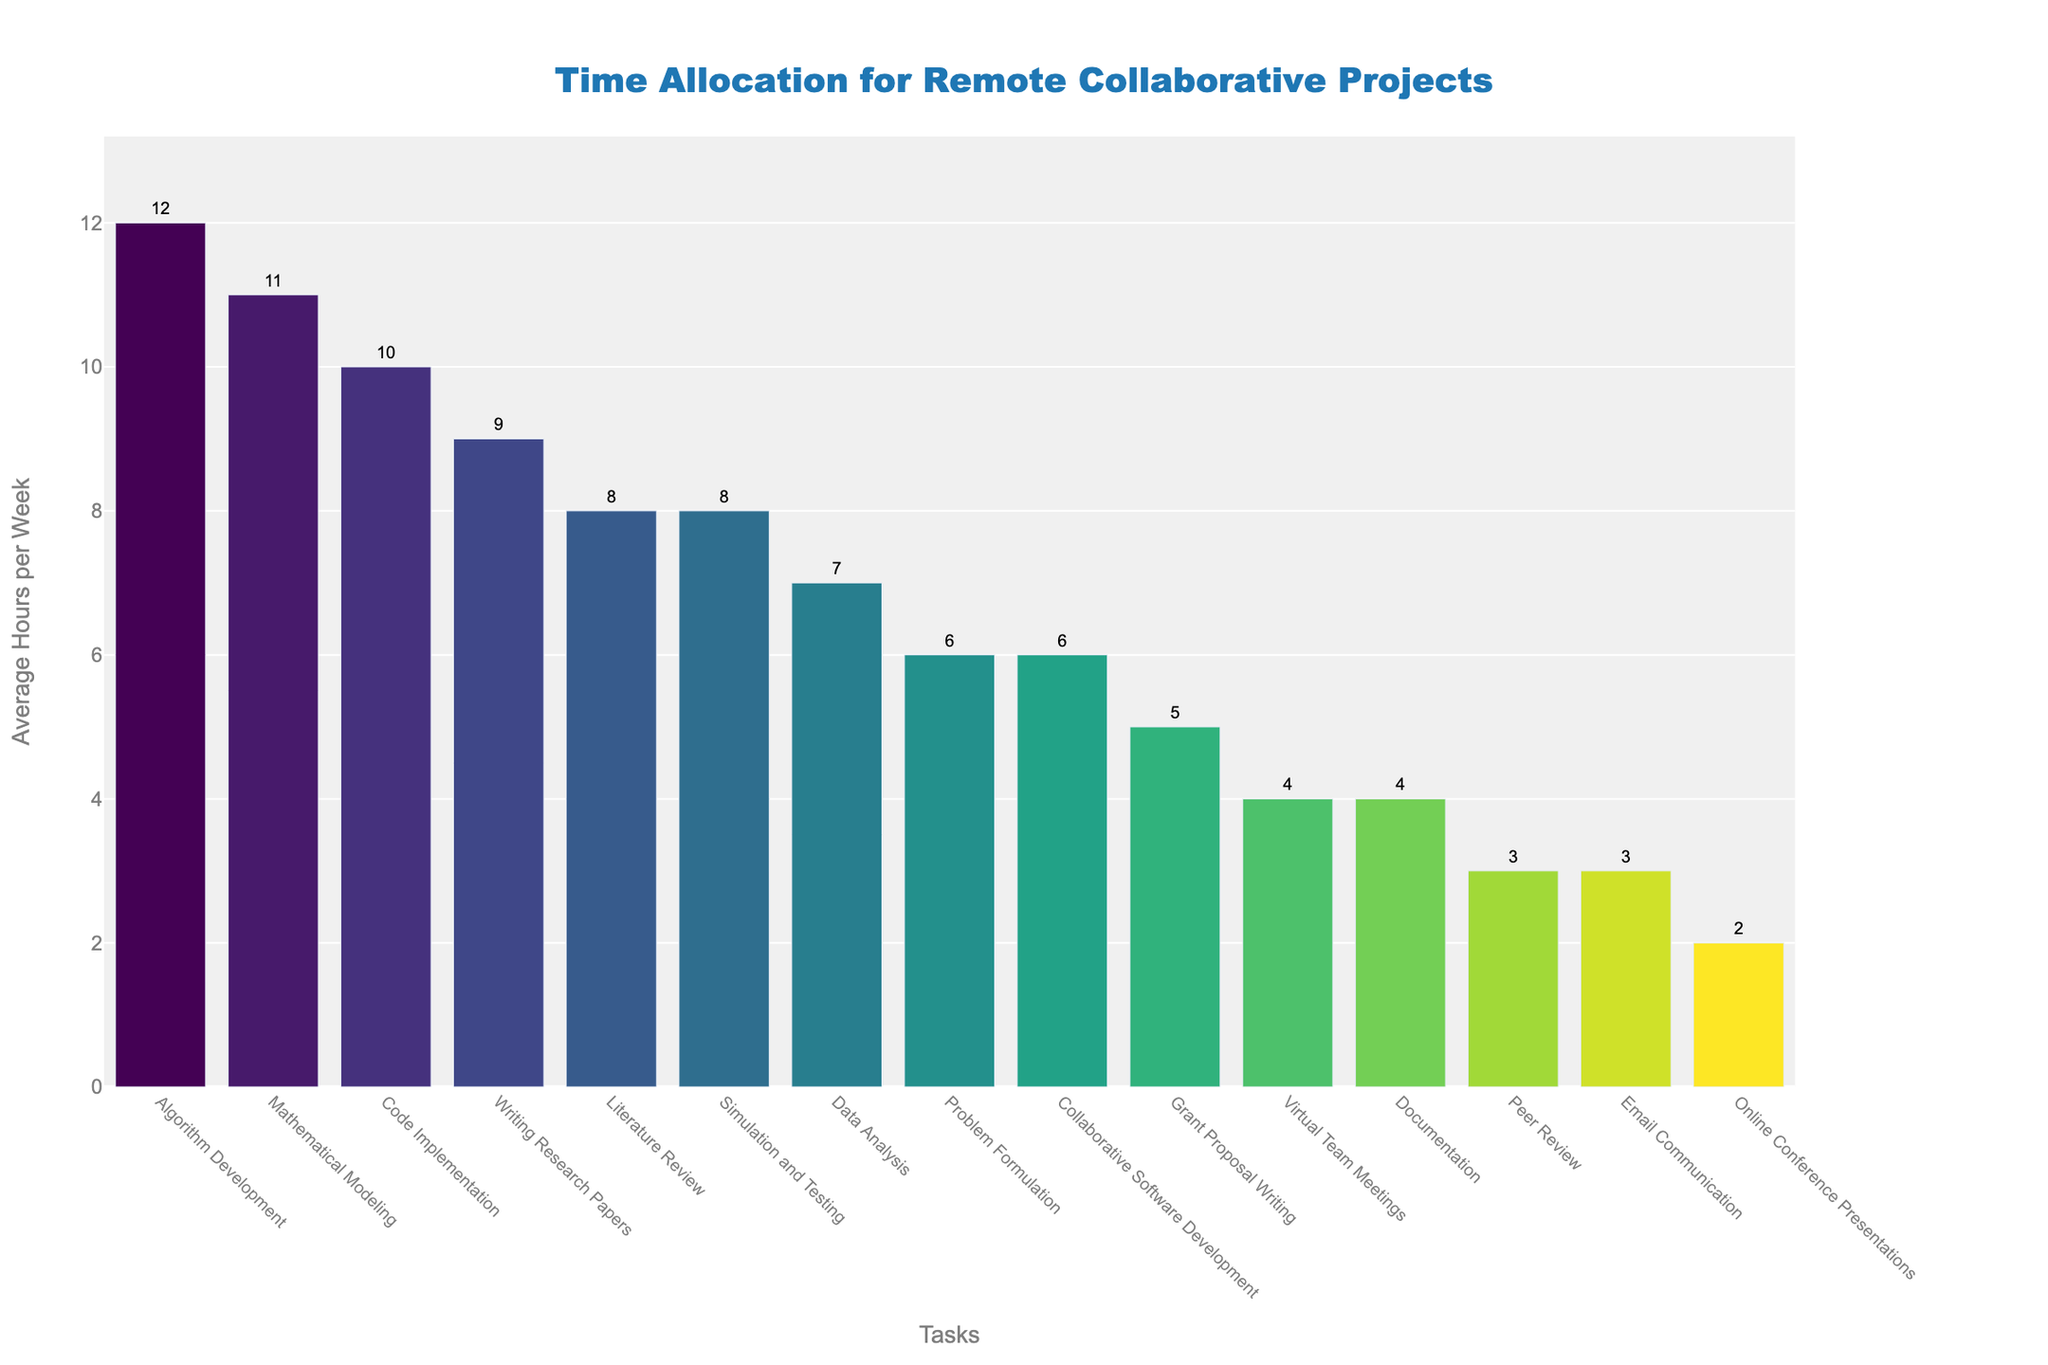Which task takes the most time per week? Identify the tallest bar in the bar chart representing "Algorithm Development" with 12 hours per week.
Answer: Algorithm Development Which task takes the least time per week? Identify the shortest bar in the bar chart representing "Online Conference Presentations" with 2 hours per week.
Answer: Online Conference Presentations How many hours are allocated to Documentation and Peer Review combined? Sum the hours for "Documentation" (4) and "Peer Review" (3). 4 + 3 = 7 hours
Answer: 7 Is the time spent on Virtual Team Meetings greater than the time spent on Email Communication? Compare the height of the bars representing "Virtual Team Meetings" (4 hours) and "Email Communication" (3 hours) to see that 4 > 3.
Answer: Yes How much more time is spent on Algorithm Development compared to Writing Research Papers? Subtract the hours for "Writing Research Papers" (9) from "Algorithm Development" (12). 12 - 9 = 3 hours
Answer: 3 Which task has nearly the same time allocation as Literature Review? Identify the bar heights closest to 8 hours, finding "Simulation and Testing" also with 8 hours per week.
Answer: Simulation and Testing What is the total time spent on Mathematical Modeling, Data Analysis, and Code Implementation? Sum the hours for "Mathematical Modeling" (11), "Data Analysis" (7), and "Code Implementation" (10). 11 + 7 + 10 = 28 hours
Answer: 28 How does the time allocated to Grant Proposal Writing compare to Problem Formulation? Compare the heights of bars representing "Grant Proposal Writing" (5 hours) and "Problem Formulation" (6 hours). 5 < 6.
Answer: Less Which task has the highest time allocation immediately followed by a task with lower time allocation? "Algorithm Development" (12 hours) followed immediately by "Mathematical Modeling" (11 hours).
Answer: Algorithm Development Out of Writing Research Papers, Email Communication, and Literature Review, which one requires the most and least time? Compare the bar heights of "Writing Research Papers" (9 hours), "Email Communication" (3 hours), and "Literature Review" (8 hours) to see that Writing Research Papers requires the most and Email Communication the least.
Answer: Writing most, Email least 